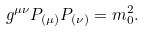Convert formula to latex. <formula><loc_0><loc_0><loc_500><loc_500>g ^ { \mu \nu } P _ { ( \mu ) } P _ { ( \nu ) } = m _ { 0 } ^ { 2 } .</formula> 